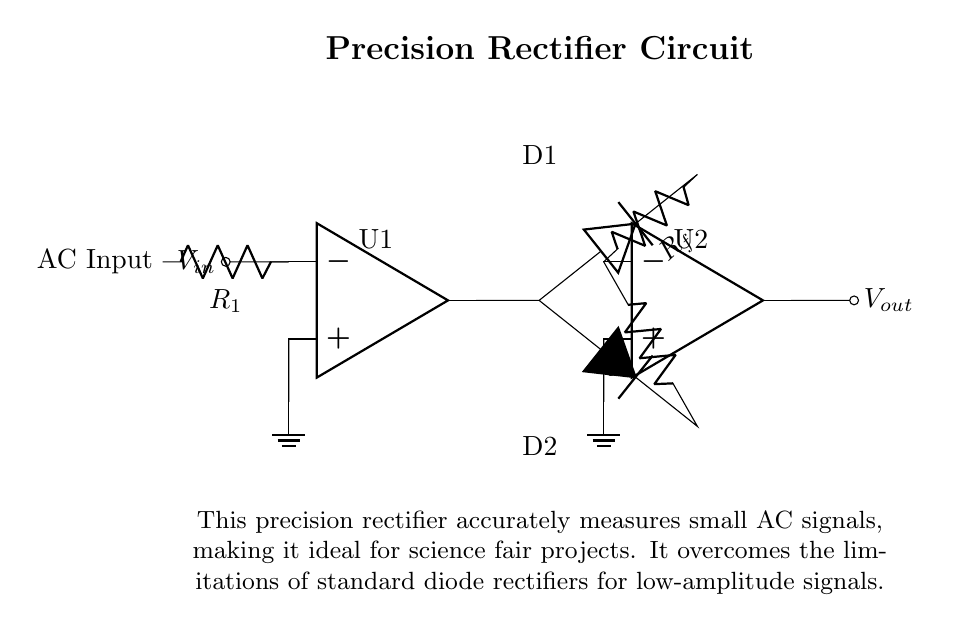What does the circuit diagram represent? The circuit diagram represents a precision rectifier circuit, designed for accurately measuring small AC signals. The diagram labels the precision rectifier, which includes op-amps and diodes that enhance accuracy over standard rectifiers.
Answer: Precision Rectifier Circuit How many operational amplifiers are used in the circuit? The circuit shows two operational amplifiers (U1 and U2) positioned within the diagram. They are indicated by the labels where the op-amps are drawn.
Answer: Two What is the purpose of the diodes in this circuit? The diodes in this circuit provide rectification, allowing current to flow in one direction while blocking it in the reverse direction. This is essential in converting the AC input into a usable DC output.
Answer: Rectification What role does the feedback resistor R_f play? The feedback resistor R_f is used to control the gain of the op-amps, which influences the output voltage magnitude and helps prevent distortion of the measured AC signal through feedback regulation.
Answer: Controls gain Why is this circuit suitable for measuring small AC signals? This circuit is suitable for measuring small AC signals as it uses precision rectification, which overcomes the limitations of standard rectifiers that may not accurately handle low-amplitude signals due to diode voltage drops.
Answer: Precision rectification What is the input to the first operational amplifier labeled as? The input to the first operational amplifier is labeled as AC Input, indicating that it receives the alternating current signal that is to be measured and rectified.
Answer: AC Input What types of signals can this precision rectifier handle? The precision rectifier can handle small AC signals effectively, particularly those that may be too weak for standard rectifiers to process accurately without significant error.
Answer: Small AC signals 